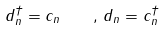<formula> <loc_0><loc_0><loc_500><loc_500>d _ { n } ^ { \dagger } = c _ { n } \quad , \, d _ { n } = c _ { n } ^ { \dagger }</formula> 